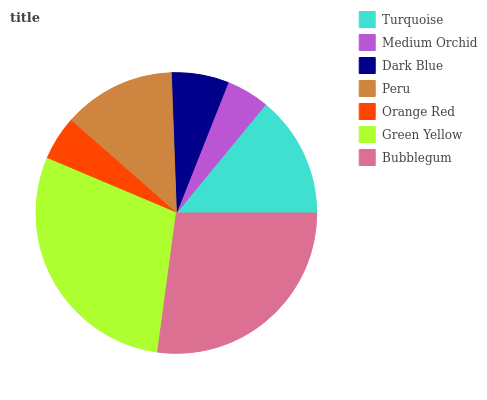Is Medium Orchid the minimum?
Answer yes or no. Yes. Is Green Yellow the maximum?
Answer yes or no. Yes. Is Dark Blue the minimum?
Answer yes or no. No. Is Dark Blue the maximum?
Answer yes or no. No. Is Dark Blue greater than Medium Orchid?
Answer yes or no. Yes. Is Medium Orchid less than Dark Blue?
Answer yes or no. Yes. Is Medium Orchid greater than Dark Blue?
Answer yes or no. No. Is Dark Blue less than Medium Orchid?
Answer yes or no. No. Is Peru the high median?
Answer yes or no. Yes. Is Peru the low median?
Answer yes or no. Yes. Is Turquoise the high median?
Answer yes or no. No. Is Turquoise the low median?
Answer yes or no. No. 